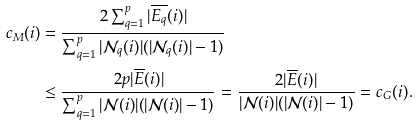Convert formula to latex. <formula><loc_0><loc_0><loc_500><loc_500>c _ { M } ( i ) & = \frac { 2 \sum _ { q = 1 } ^ { p } | \overline { E _ { q } } ( i ) | } { \sum _ { q = 1 } ^ { p } | \mathcal { N } _ { q } ( i ) | ( | \mathcal { N } _ { q } ( i ) | - 1 ) } \\ & \leq \frac { 2 p | \overline { E } ( i ) | } { \sum _ { q = 1 } ^ { p } | \mathcal { N } ( i ) | ( | \mathcal { N } ( i ) | - 1 ) } = \frac { 2 | \overline { E } ( i ) | } { | \mathcal { N } ( i ) | ( | \mathcal { N } ( i ) | - 1 ) } = c _ { G } ( i ) .</formula> 